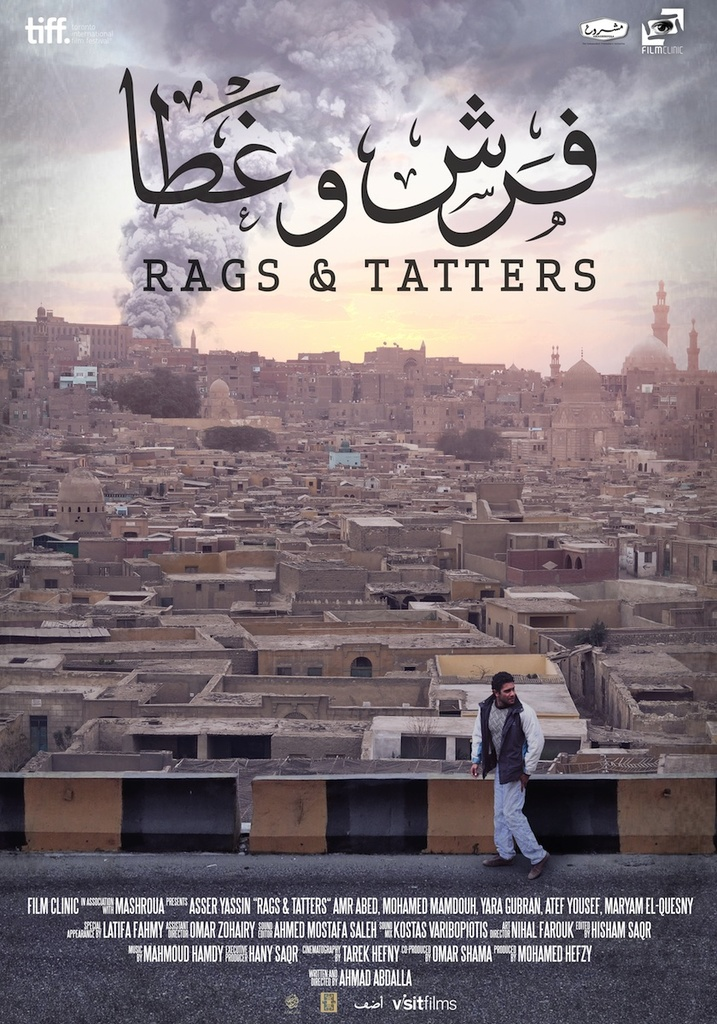How does the inclusion of the mosque in the background enhance the narrative or thematic significance of the poster? The presence of the mosque in the background not only adds to the geographic and cultural setting of the narrative but also hints at possible religious or cultural elements interwoven within the plot. In cinema, such landmarks often symbolize community and faith, potentially pointing towards underlying themes of community bonds, cultural identity, or moral conflicts within the storyline. The visible prominence of the mosque might suggest that these elements are pivotal to the protagonist's journey or to the conflict within the community depicted in the film. 